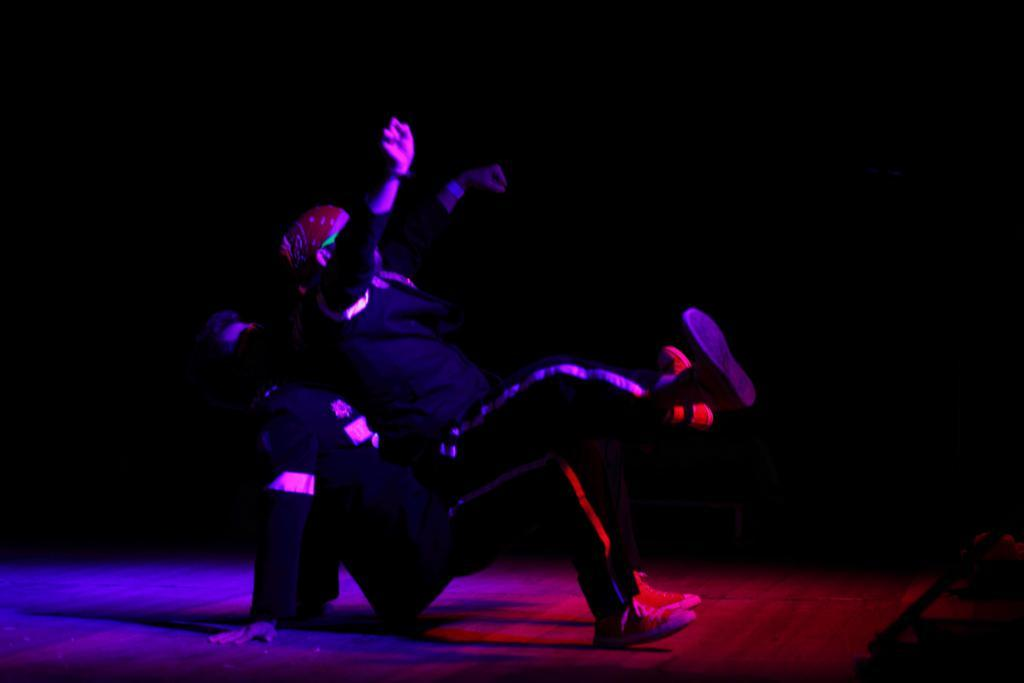What are the two persons in the image doing? The two persons in the image are dancing. What is at the bottom of the image? There is a floor at the bottom of the image. How would you describe the background of the image? The background of the image is dark. What time of day is it in the image, considering it's a work morning? The provided facts do not mention the time of day or any reference to work or morning, so it cannot be determined from the image. 